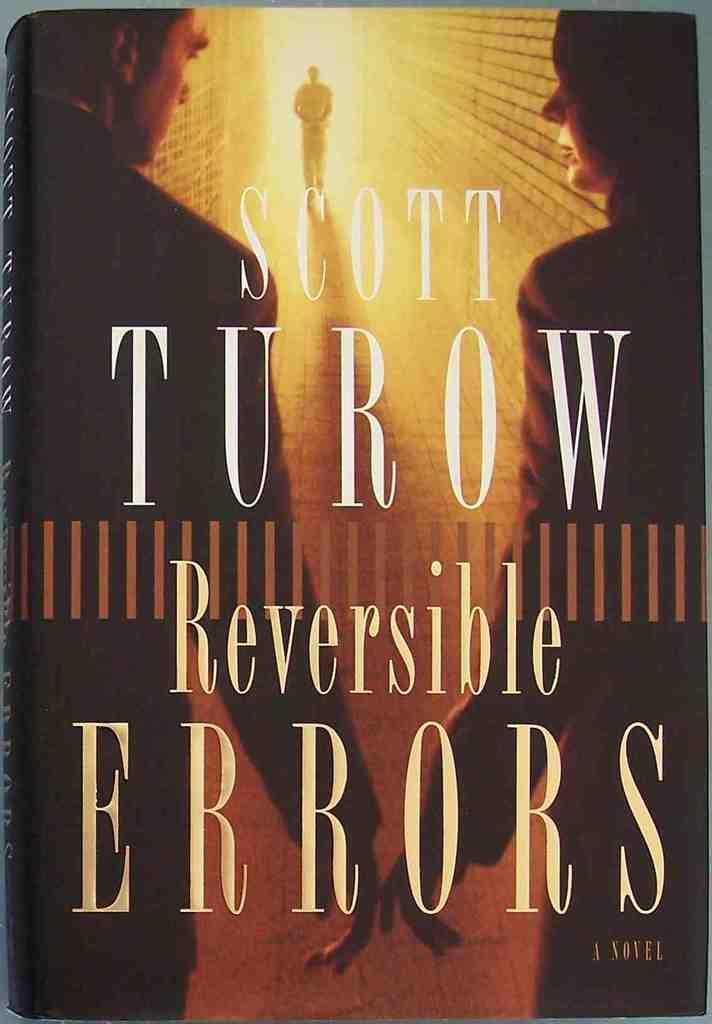What is the main subject of the image? The main subject of the image is the cover of a book. What type of toy can be seen on the cover of the book? There is no toy present on the cover of the book; it only features the book cover. 